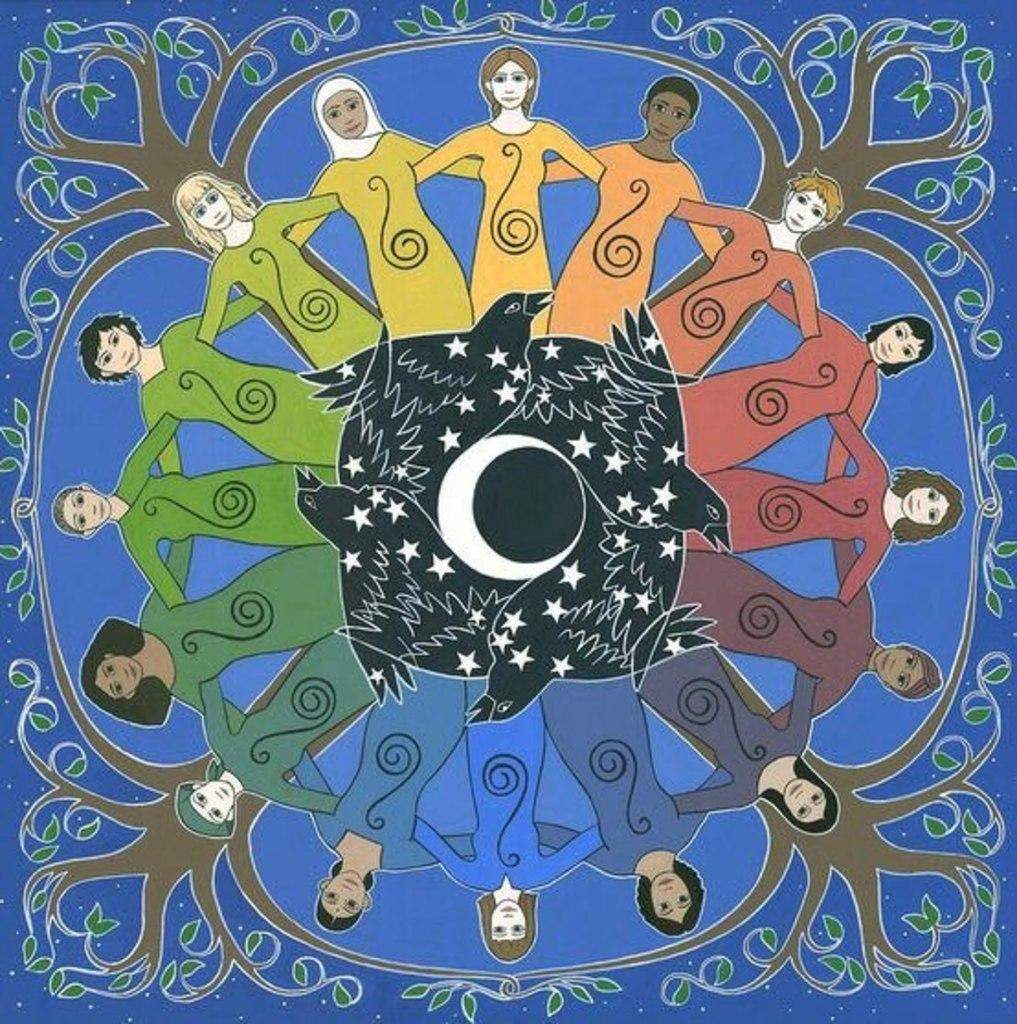What type of picture is the image? The image is an animated picture. What type of natural elements can be seen in the image? There are trees in the image. Who or what is present in the image? There are persons and birds in the image. What songs are the beginner birds singing in the image? There are no birds singing in the image, and there is no indication of their skill level. 